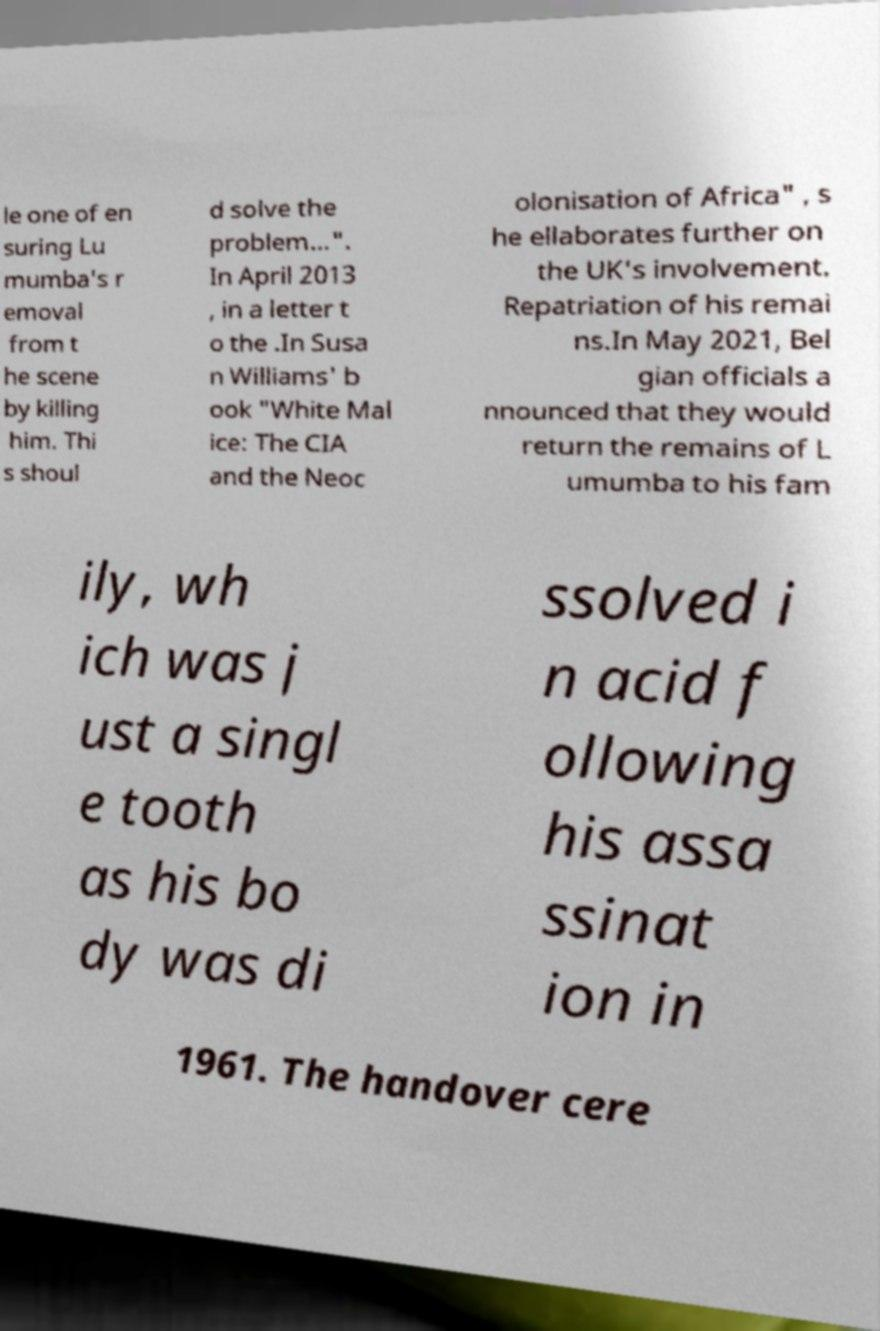Can you accurately transcribe the text from the provided image for me? le one of en suring Lu mumba's r emoval from t he scene by killing him. Thi s shoul d solve the problem...". In April 2013 , in a letter t o the .In Susa n Williams' b ook "White Mal ice: The CIA and the Neoc olonisation of Africa" , s he ellaborates further on the UK's involvement. Repatriation of his remai ns.In May 2021, Bel gian officials a nnounced that they would return the remains of L umumba to his fam ily, wh ich was j ust a singl e tooth as his bo dy was di ssolved i n acid f ollowing his assa ssinat ion in 1961. The handover cere 